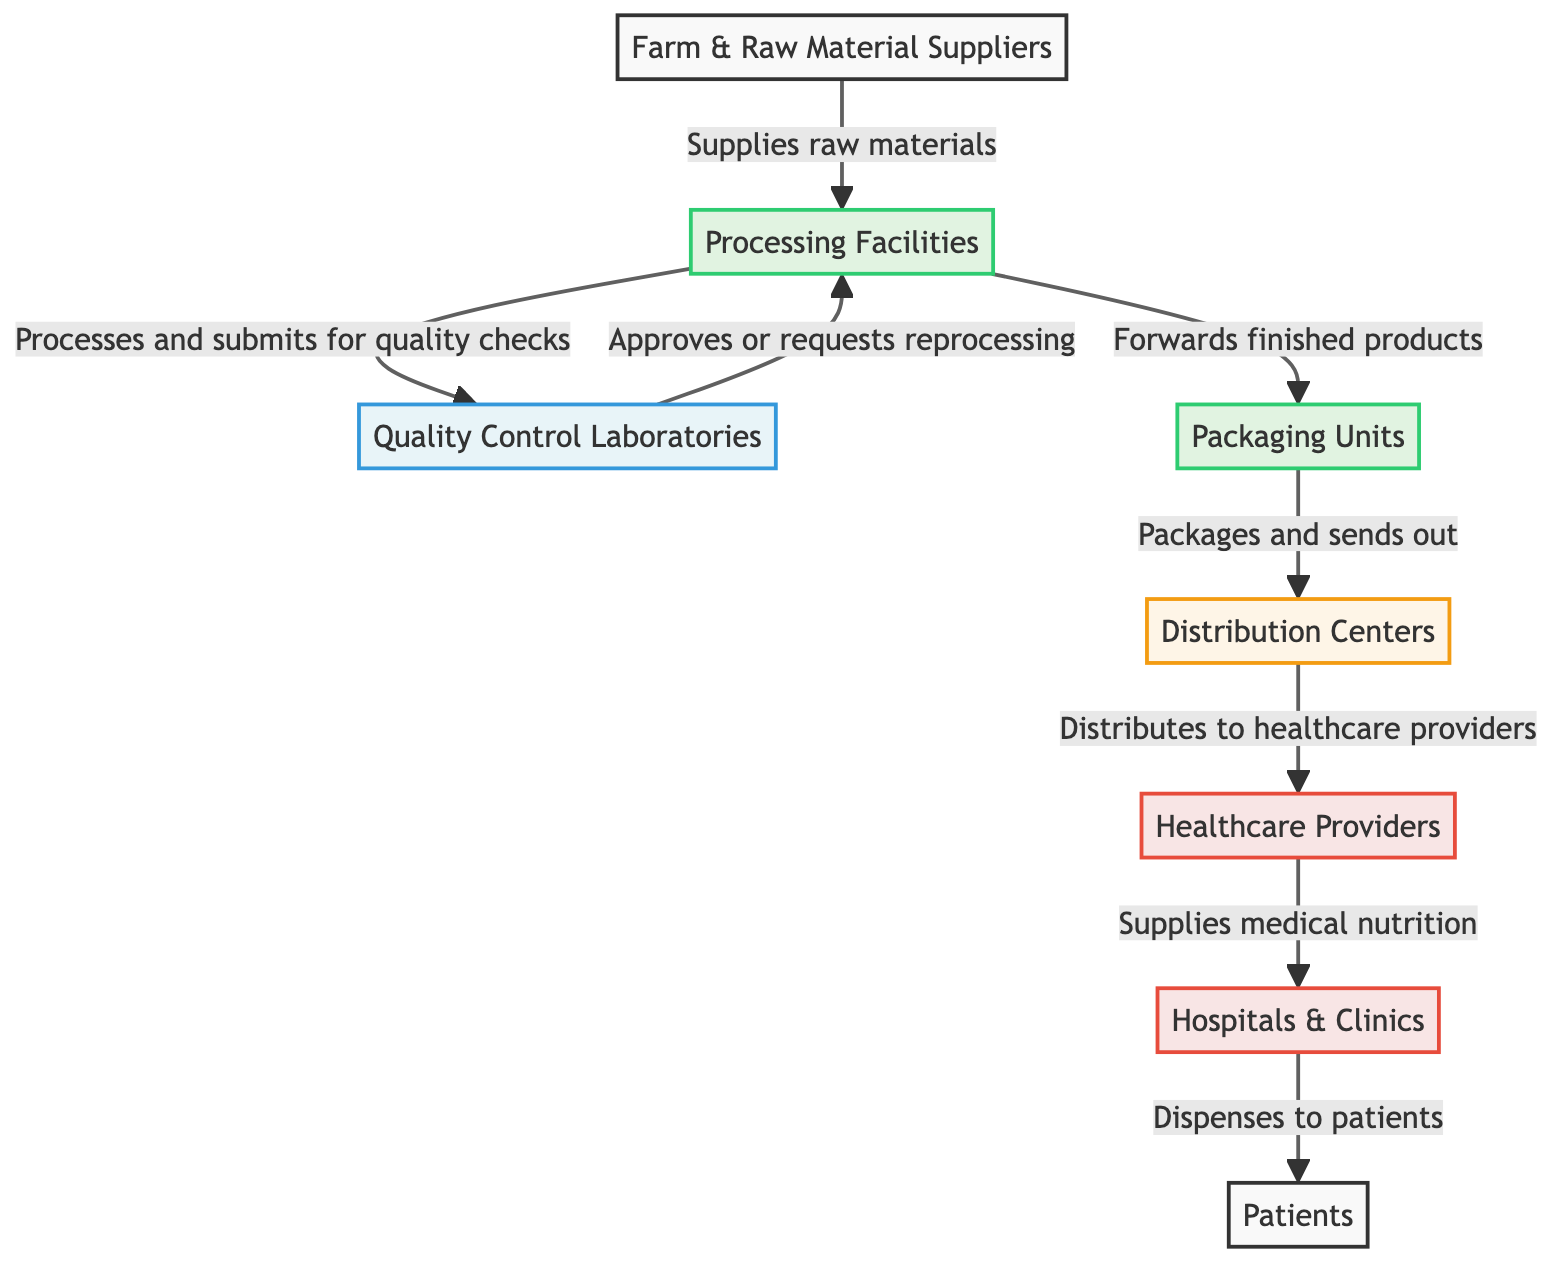What is the first node in the supply chain? The diagram starts with the "Farm & Raw Material Suppliers," which is the first node representing the origin of raw materials in the supply chain.
Answer: Farm & Raw Material Suppliers How many nodes are connected to the Processing Facilities? The Processing Facilities node is connected to three other nodes: Quality Control Laboratories, Packaging Units, and Farm & Raw Material Suppliers.
Answer: 3 What is the role of Quality Control Laboratories? Quality Control Laboratories check the products processed in the Processing Facilities and either approve them or request reprocessing, indicating their role in maintaining product quality.
Answer: Approves or requests reprocessing Which node directly supplies medical nutrition to Hospitals & Clinics? The Distribution Centers distribute the medical nutrition products to Healthcare Providers, who then supply it to Hospitals & Clinics.
Answer: Healthcare Providers What is the final step in the supply chain before patients receive medical nutrition? The final step before patients receive medical nutrition occurs at Hospitals & Clinics, where the products are dispensed to patients, marking the end of the supply chain process.
Answer: Dispenses to patients Which node is responsible for packaging the finished products? The Packaging Units are designated within the diagram as the responsible node for packaging the finished products after processing has been completed.
Answer: Packaging Units How many types of entities are involved in the supply chain? There are four types of entities involved: Suppliers, Processing Facilities, Quality Control Laboratories, and Healthcare Providers, making a total of four distinct types.
Answer: 4 What is the flow direction from Packaging Units? The flow direction from Packaging Units is towards the Distribution Centers, indicating that packaged products are sent out for further distribution.
Answer: Distributes to Healthcare Providers Which node follows the Quality Control Laboratories in the supply chain? After the Quality Control Laboratories, the next node in the flow is the Packaging Units, where the products are packaged for distribution.
Answer: Packaging Units 